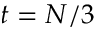Convert formula to latex. <formula><loc_0><loc_0><loc_500><loc_500>t = N / 3</formula> 